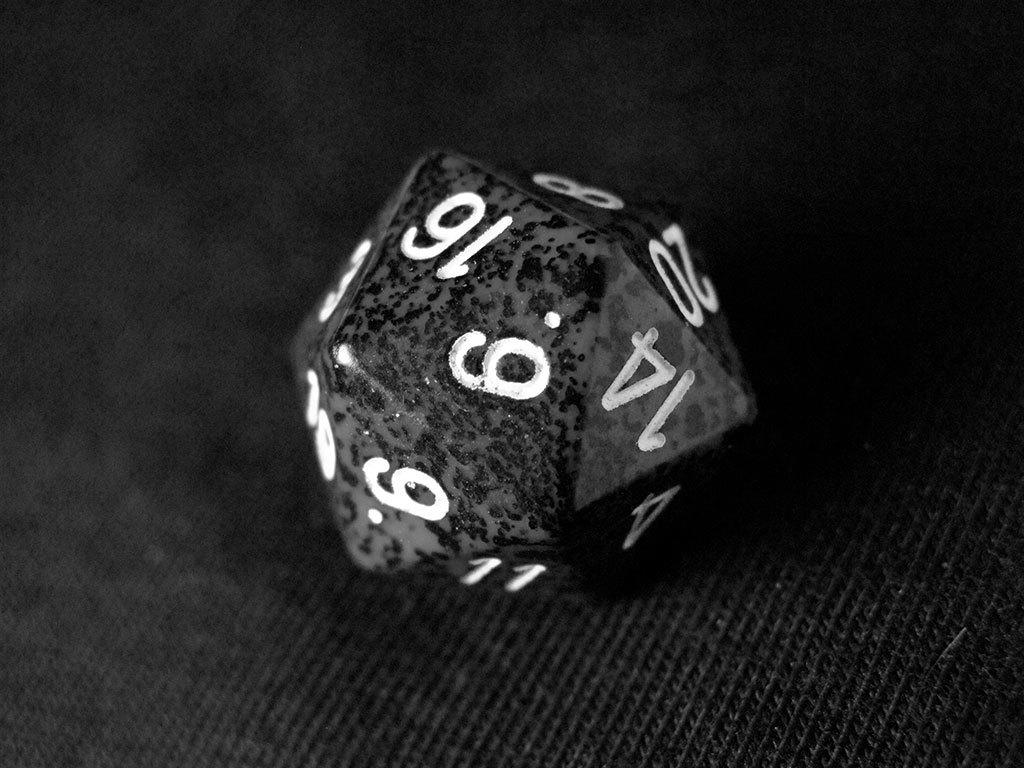What is the color scheme of the image? The image is black and white. What object can be seen at the bottom of the image? There is a black color object at the bottom of the image, which seems like a mat. What is the main object in the middle of the image? There is a dice in the middle of the image. What can be found on the dice? The dice has numbers on it. How many teeth does the dice have in the image? The dice does not have teeth; it has numbers on its sides. What type of expert is needed to sort the colors in the image? There are no colors to sort in the image, as it is black and white. 